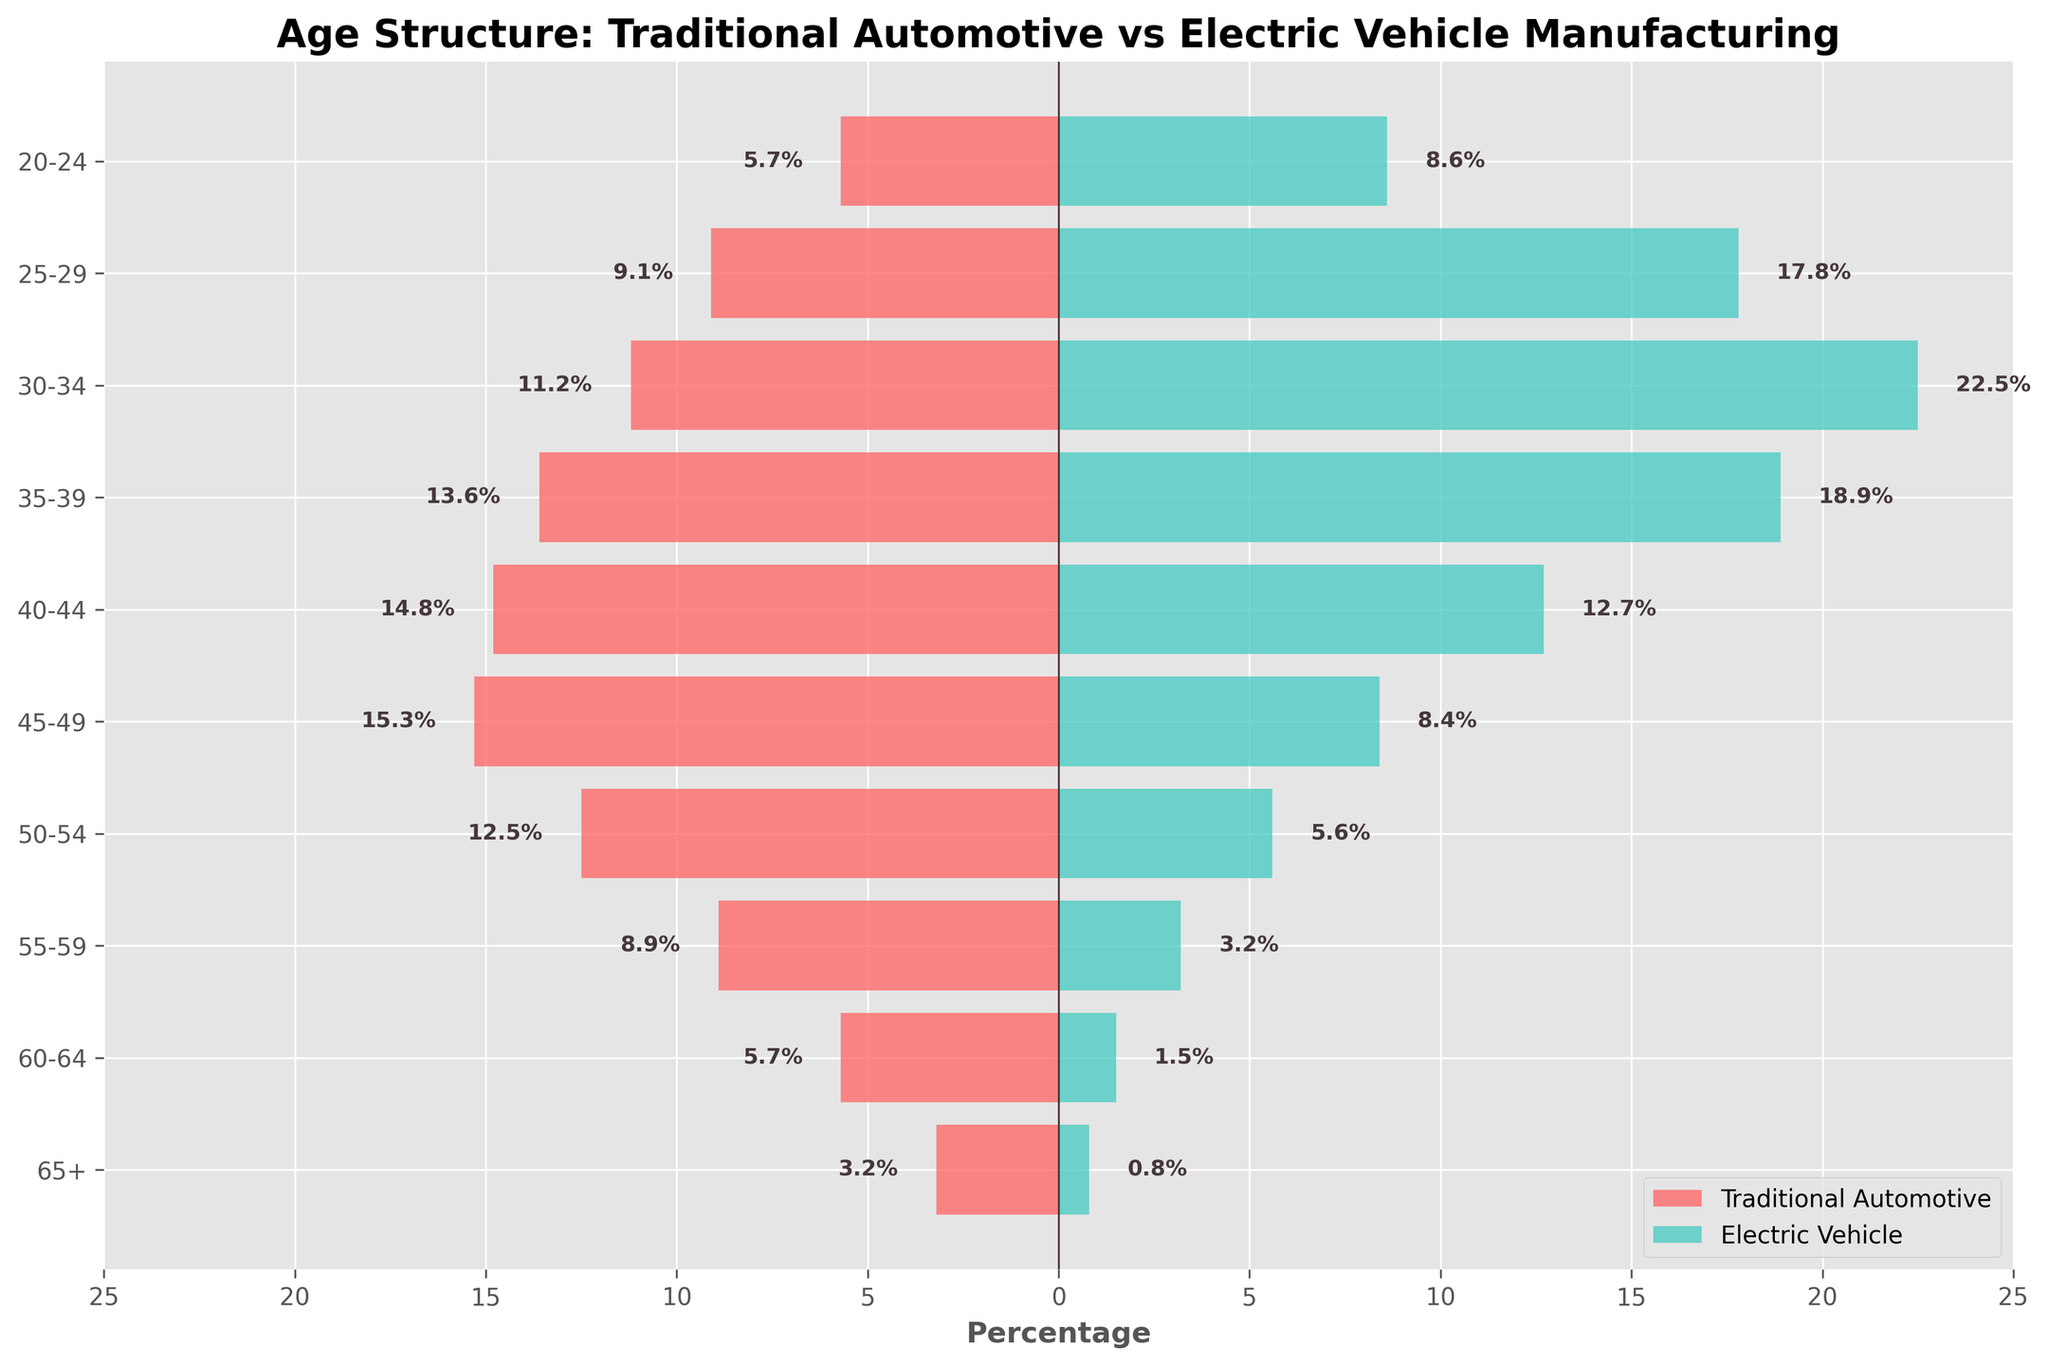What's the title of the figure? The title is usually placed at the top of the figure, and in this case, it reads "Age Structure: Traditional Automotive vs Electric Vehicle Manufacturing".
Answer: Age Structure: Traditional Automotive vs Electric Vehicle Manufacturing What is the youngest age group listed in the figure? The age groups are listed on the y-axis, and the youngest age group at the bottom is "20-24".
Answer: 20-24 Which age group has the highest percentage in the Electric Vehicle manufacturing category? By observing the lengths of the bars on the right side (Electric Vehicle), the "30-34" age group has the longest bar, indicating the highest percentage.
Answer: 30-34 How many age groups are represented in the figure? Count the number of labels on the y-axis to determine the number of age groups, which are 10.
Answer: 10 What is the percentage difference between the 50-54 age group in both categories? For the 50-54 age group, subtract the Electric Vehicle percentage (5.6%) from the Traditional Automotive percentage (12.5%). The difference is 12.5% - 5.6% = 6.9%.
Answer: 6.9% Compare the percentages of the 35-39 age group in both categories. Which one is higher and by how much? The 35-39 age group has 13.6% in Traditional Automotive and 18.9% in Electric Vehicle. Subtract the Traditional percentage from the Electric Vehicle percentage: 18.9% - 13.6% = 5.3%. Electric Vehicle is higher by 5.3%.
Answer: Electric Vehicle, 5.3% Which category has a higher percentage of employees aged 65+? Compare the bars for "65+" in both categories. Traditional Automotive has a longer bar (3.2%) compared to Electric Vehicle (0.8%).
Answer: Traditional Automotive What is the total percentage of employees aged 25-29 and 20-24 in the Electric Vehicle manufacturing category? Add the percentages for the 25-29 (17.8%) and 20-24 (8.6%) age groups in Electric Vehicle: 17.8% + 8.6% = 26.4%.
Answer: 26.4% Is there an age group where the percentage of employees is equal in both categories? By comparing all pairs of bars for each age group, no age group has the same percentage value in both categories.
Answer: No What trend do you observe in the age structure of Electric Vehicle manufacturing employees compared to Traditional Automotive? The figure shows that younger age groups (20-34) have higher percentages in Electric Vehicle manufacturing, while older age groups (50+) have higher percentages in Traditional Automotive. This suggests a younger workforce in Electric Vehicle compared to an older workforce in Traditional Automotive.
Answer: Younger workforce in Electric Vehicle, older in Traditional Automotive 